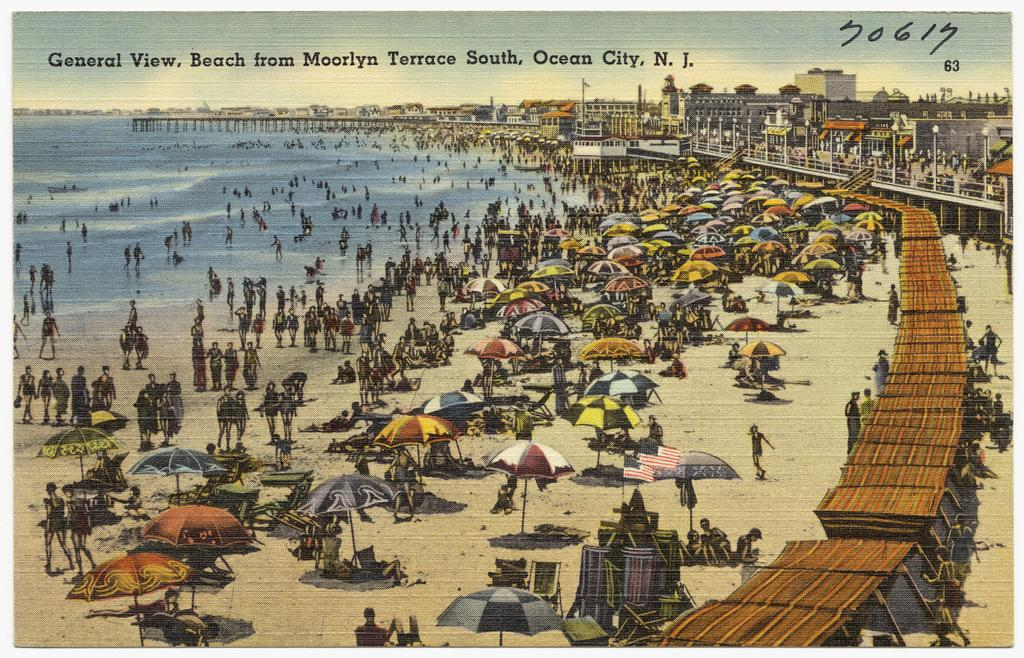How many people are present in the image? There are people in the image, but the exact number is not specified. What are the people holding in the image? The people are holding umbrellas in the image. What type of temporary shelters can be seen in the image? There are tents in the image. What type of structures are visible in the image? There are buildings in the image. What natural element is visible in the image? Water is visible in the image. What part of the sky is visible in the image? The sky is visible in the image. What is the amount of twigs present in the image? There is no mention of twigs in the image, so it is impossible to determine the amount. 